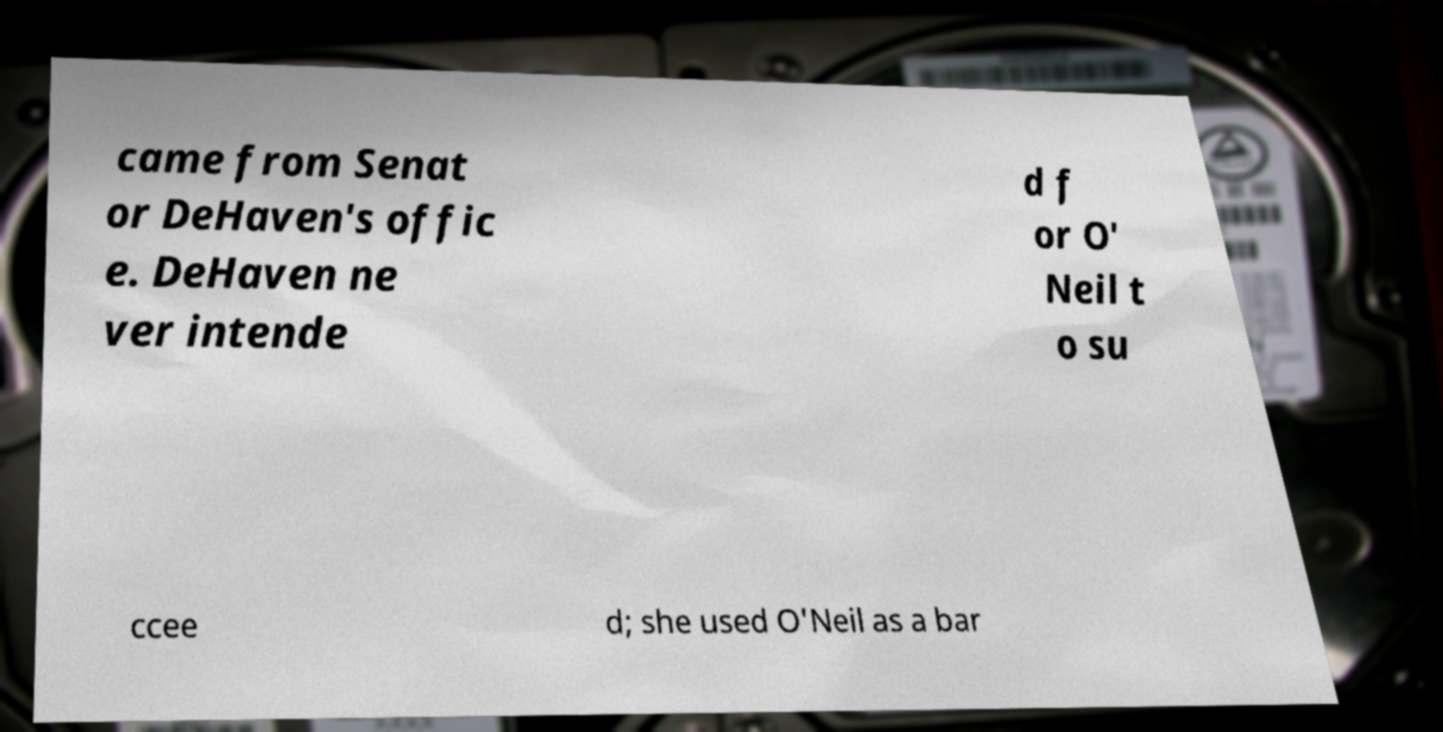I need the written content from this picture converted into text. Can you do that? came from Senat or DeHaven's offic e. DeHaven ne ver intende d f or O' Neil t o su ccee d; she used O'Neil as a bar 